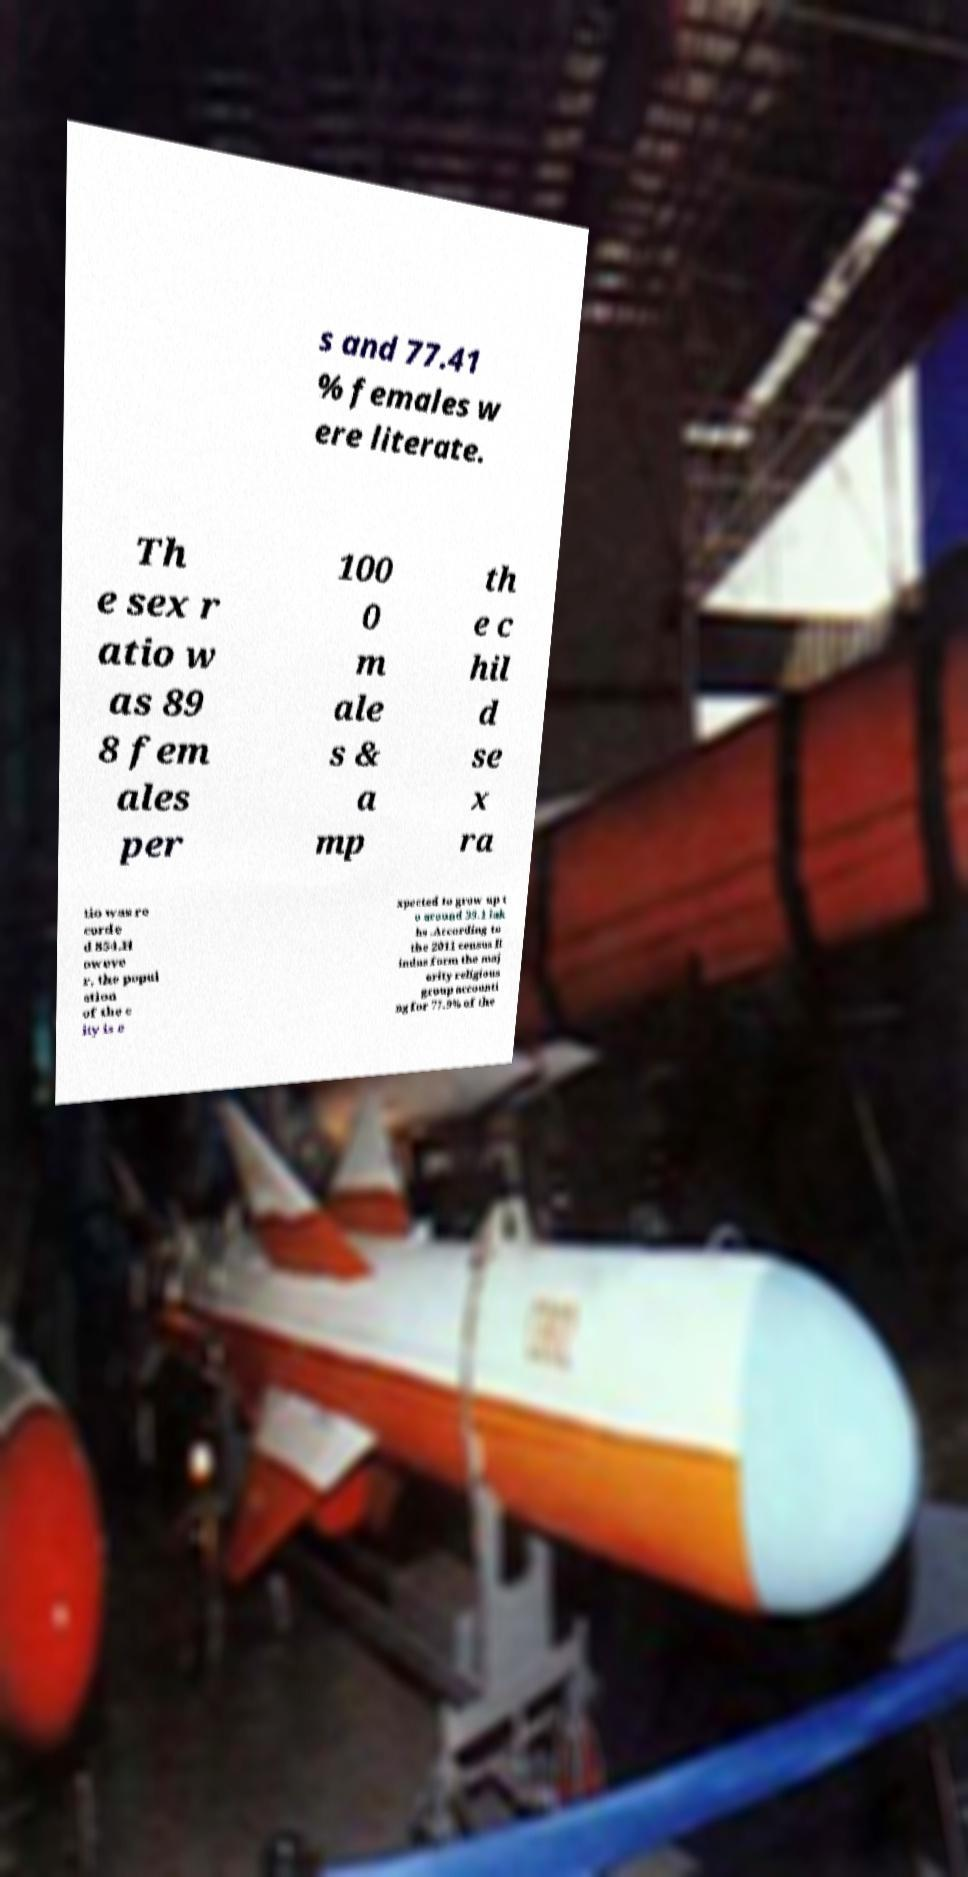Please read and relay the text visible in this image. What does it say? s and 77.41 % females w ere literate. Th e sex r atio w as 89 8 fem ales per 100 0 m ale s & a mp th e c hil d se x ra tio was re corde d 854.H oweve r, the popul ation of the c ity is e xpected to grow up t o around 39.1 lak hs .According to the 2011 census H indus form the maj ority religious group accounti ng for 77.9% of the 